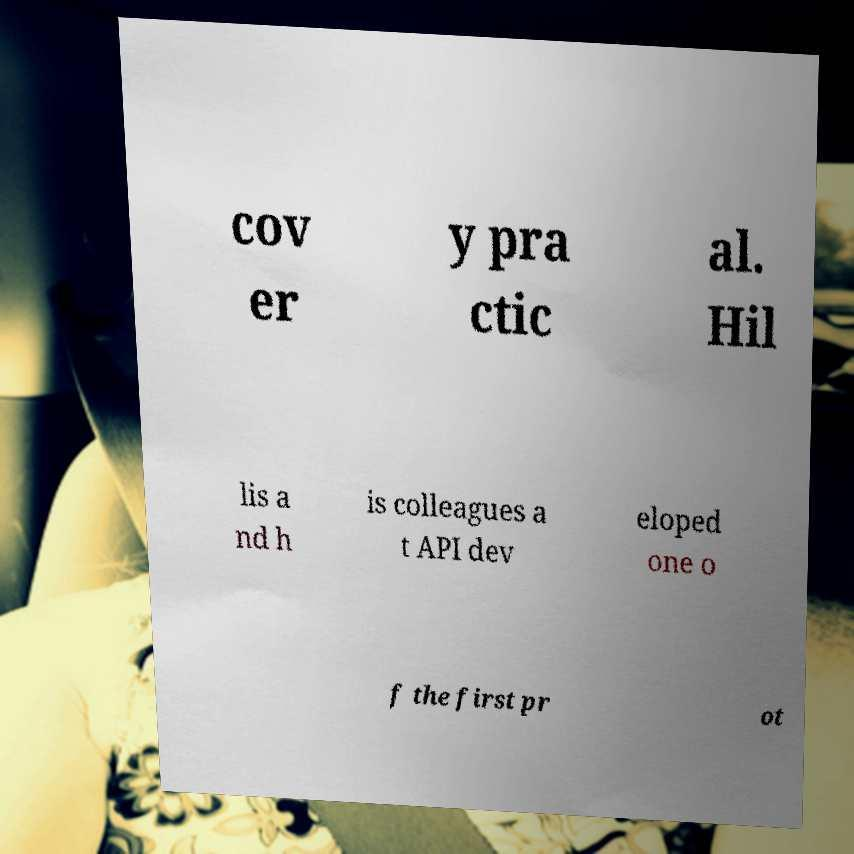Could you assist in decoding the text presented in this image and type it out clearly? cov er y pra ctic al. Hil lis a nd h is colleagues a t API dev eloped one o f the first pr ot 